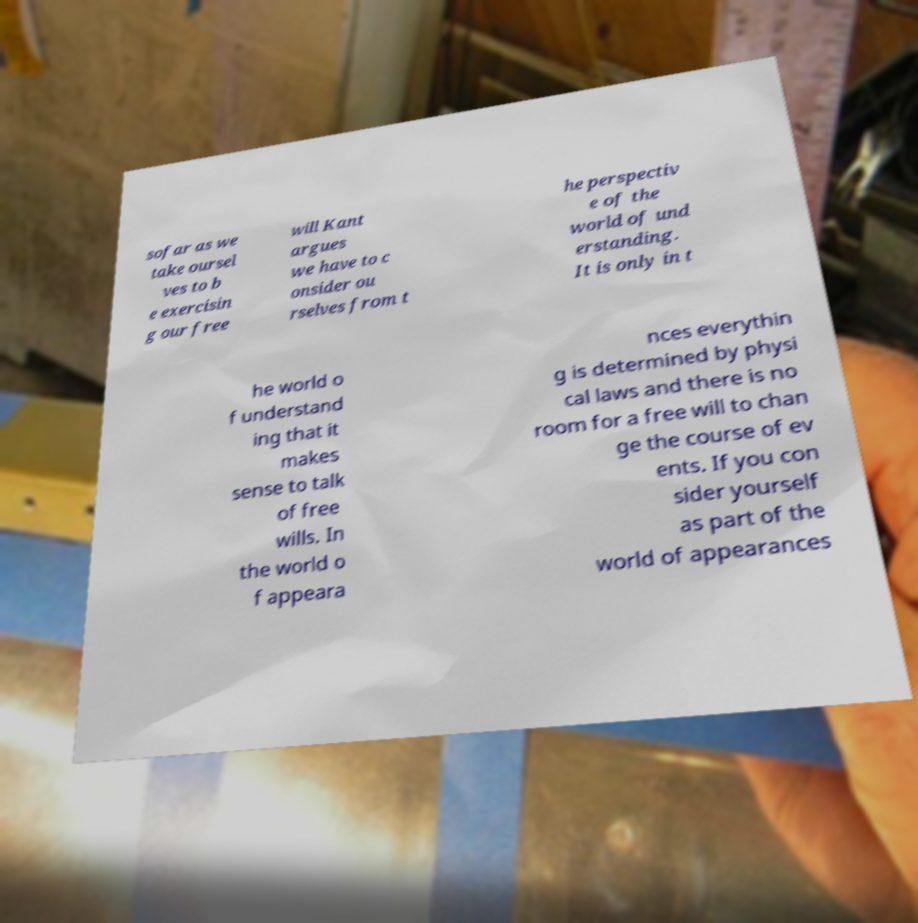Can you accurately transcribe the text from the provided image for me? sofar as we take oursel ves to b e exercisin g our free will Kant argues we have to c onsider ou rselves from t he perspectiv e of the world of und erstanding. It is only in t he world o f understand ing that it makes sense to talk of free wills. In the world o f appeara nces everythin g is determined by physi cal laws and there is no room for a free will to chan ge the course of ev ents. If you con sider yourself as part of the world of appearances 